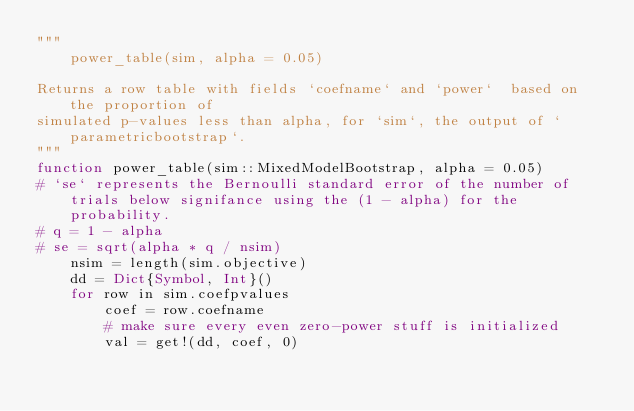<code> <loc_0><loc_0><loc_500><loc_500><_Julia_>"""
    power_table(sim, alpha = 0.05)

Returns a row table with fields `coefname` and `power`  based on the proportion of
simulated p-values less than alpha, for `sim`, the output of `parametricbootstrap`.
"""
function power_table(sim::MixedModelBootstrap, alpha = 0.05)
# `se` represents the Bernoulli standard error of the number of trials below signifance using the (1 - alpha) for the probability.
# q = 1 - alpha
# se = sqrt(alpha * q / nsim)
    nsim = length(sim.objective)
    dd = Dict{Symbol, Int}()
    for row in sim.coefpvalues
        coef = row.coefname
        # make sure every even zero-power stuff is initialized
        val = get!(dd, coef, 0)</code> 